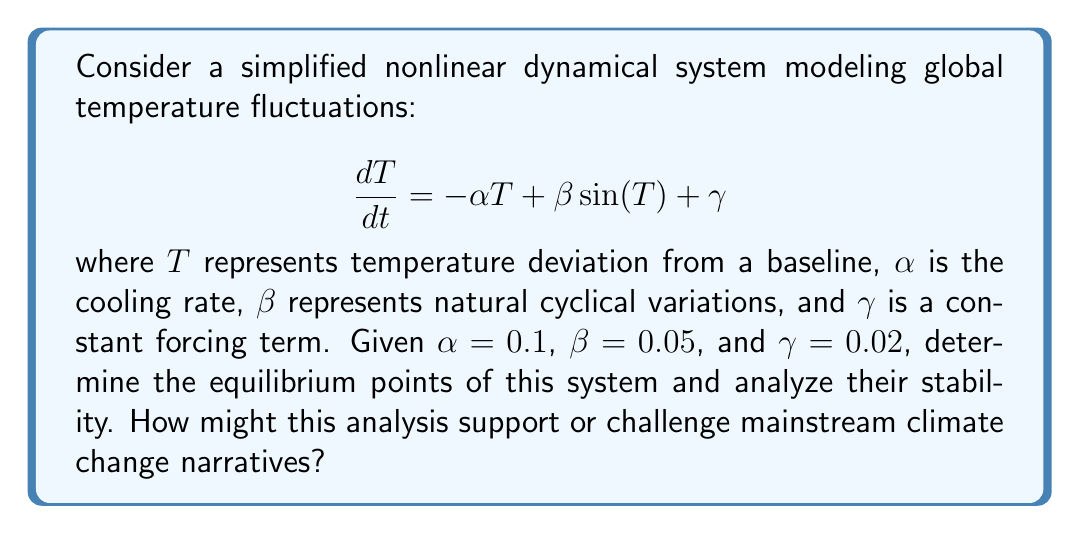Can you answer this question? 1) First, we find the equilibrium points by setting $\frac{dT}{dt} = 0$:

   $$0 = -0.1T + 0.05\sin(T) + 0.02$$

2) This transcendental equation can't be solved analytically. We can use numerical methods or graphical analysis to find the solutions.

3) Graphically, we're looking for intersections of $y = 0.1T - 0.02$ and $y = 0.05\sin(T)$. This occurs at approximately $T \approx 0.2$ and $T \approx 6.1$.

4) To analyze stability, we calculate the Jacobian (in this 1D case, it's just the derivative):

   $$J = \frac{d}{dT}(-0.1T + 0.05\sin(T) + 0.02) = -0.1 + 0.05\cos(T)$$

5) Evaluate J at each equilibrium point:
   For $T \approx 0.2$: $J \approx -0.1 + 0.05\cos(0.2) \approx -0.05 < 0$ (stable)
   For $T \approx 6.1$: $J \approx -0.1 + 0.05\cos(6.1) \approx -0.15 < 0$ (stable)

6) Both equilibrium points are stable, indicating that the system tends to settle into one of two states, depending on initial conditions.

7) This simplified model suggests multiple stable states in temperature dynamics, which could be used to argue that climate systems have natural, stable variations. However, it's crucial to note that this model is greatly simplified and doesn't account for many factors considered in comprehensive climate models.
Answer: Two stable equilibrium points: $T \approx 0.2$ and $T \approx 6.1$ 